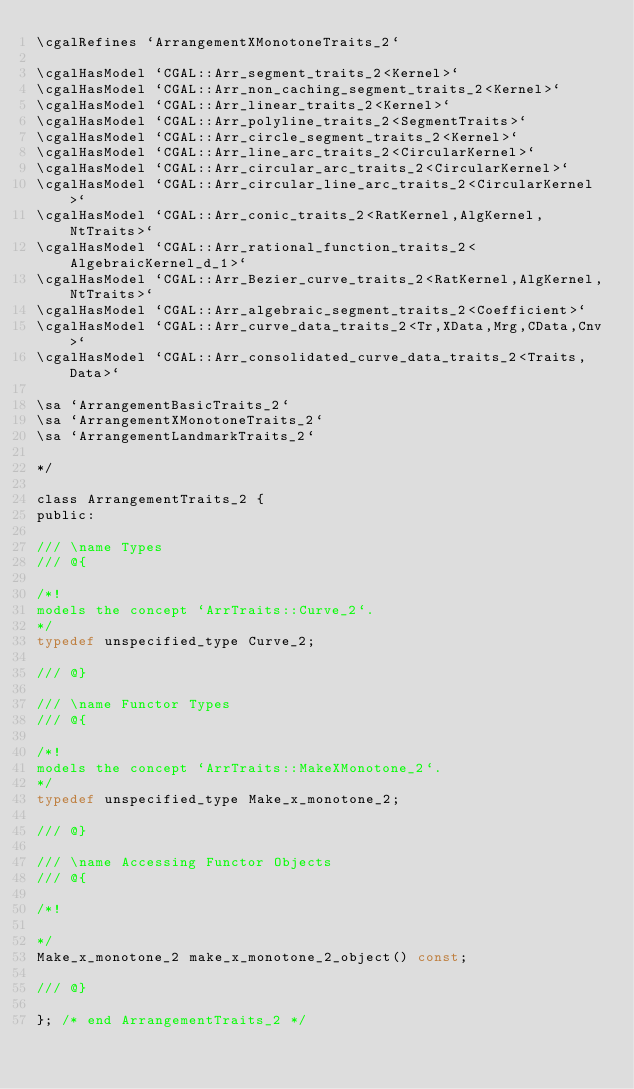Convert code to text. <code><loc_0><loc_0><loc_500><loc_500><_C_>\cgalRefines `ArrangementXMonotoneTraits_2` 

\cgalHasModel `CGAL::Arr_segment_traits_2<Kernel>`
\cgalHasModel `CGAL::Arr_non_caching_segment_traits_2<Kernel>`
\cgalHasModel `CGAL::Arr_linear_traits_2<Kernel>`
\cgalHasModel `CGAL::Arr_polyline_traits_2<SegmentTraits>`
\cgalHasModel `CGAL::Arr_circle_segment_traits_2<Kernel>`
\cgalHasModel `CGAL::Arr_line_arc_traits_2<CircularKernel>`
\cgalHasModel `CGAL::Arr_circular_arc_traits_2<CircularKernel>`
\cgalHasModel `CGAL::Arr_circular_line_arc_traits_2<CircularKernel>`
\cgalHasModel `CGAL::Arr_conic_traits_2<RatKernel,AlgKernel,NtTraits>`
\cgalHasModel `CGAL::Arr_rational_function_traits_2<AlgebraicKernel_d_1>`
\cgalHasModel `CGAL::Arr_Bezier_curve_traits_2<RatKernel,AlgKernel,NtTraits>`
\cgalHasModel `CGAL::Arr_algebraic_segment_traits_2<Coefficient>`
\cgalHasModel `CGAL::Arr_curve_data_traits_2<Tr,XData,Mrg,CData,Cnv>`
\cgalHasModel `CGAL::Arr_consolidated_curve_data_traits_2<Traits,Data>`

\sa `ArrangementBasicTraits_2` 
\sa `ArrangementXMonotoneTraits_2` 
\sa `ArrangementLandmarkTraits_2` 

*/

class ArrangementTraits_2 {
public:

/// \name Types 
/// @{

/*!
models the concept `ArrTraits::Curve_2`. 
*/ 
typedef unspecified_type Curve_2; 

/// @} 

/// \name Functor Types 
/// @{

/*!
models the concept `ArrTraits::MakeXMonotone_2`. 
*/ 
typedef unspecified_type Make_x_monotone_2; 

/// @} 

/// \name Accessing Functor Objects 
/// @{

/*!

*/ 
Make_x_monotone_2 make_x_monotone_2_object() const; 

/// @}

}; /* end ArrangementTraits_2 */

</code> 